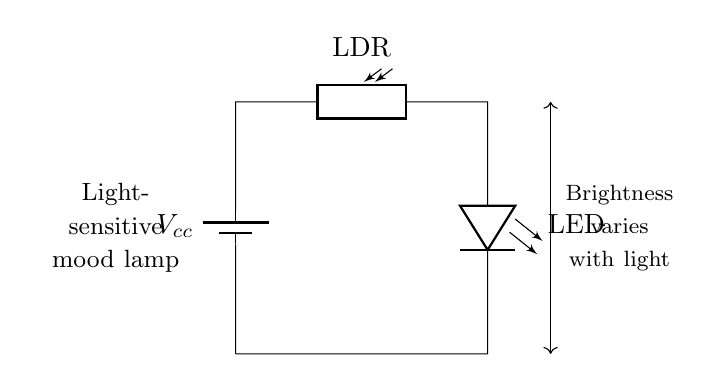What is the main component that detects light in this circuit? The main component that detects light in this circuit is the photoresistor, commonly known as an LDR. It changes its resistance based on the brightness of light, which allows the circuit to be light-sensitive.
Answer: photoresistor What is the output device in this circuit? The output device in this circuit is the LED, which emits light when current flows through it. The LED's brightness will vary depending on the resistance of the photoresistor based on the ambient light conditions.
Answer: LED What happens to the LED when the light level decreases? When the light level decreases, the resistance of the photoresistor increases. This reduces the current flowing through the circuit, causing the LED to dim or turn off.
Answer: LED dims How many components are connected in series in this circuit? The circuit consists of three main components connected in series: the battery, photoresistor, and LED. Each component is connected end-to-end, meaning the current flows through each component sequentially.
Answer: three What effect does increasing the light intensity have on the LED? Increasing the light intensity causes the resistance of the photoresistor to decrease. As a result, more current flows through the circuit, leading to a brighter LED. This relationship allows the mood lamp to adjust its brightness according to surrounding light.
Answer: LED brightens What is the function of the battery in this circuit? The battery provides the necessary voltage to drive current through the circuit. It acts as the power source, establishing a potential difference that allows the other components to operate.
Answer: power source What type of circuit is illustrated in this diagram? The diagram illustrates a series circuit, where all components are connected in a single path. This means that the same current flows through the photoresistor and the LED, and if one component fails, the entire circuit will stop functioning.
Answer: series circuit 